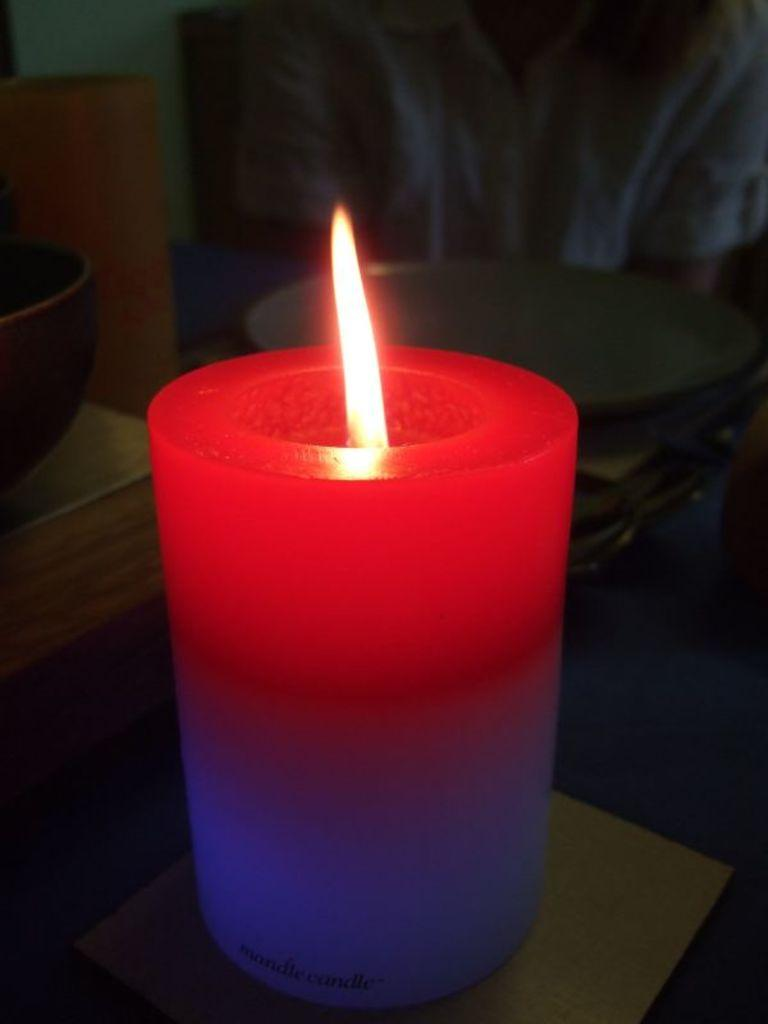What is the main source of light in the image? There is a candle in the image, which is the main source of light. What is happening to the candle in the image? There is fire in the image, which means the candle is lit. What can be seen in the background of the image? There are objects visible in the background of the image. What type of potato is being washed in the image? There is no potato or washing activity present in the image. 